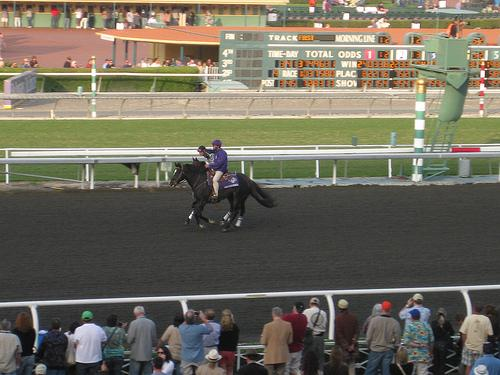Briefly describe the central event in the image and the primary figures involved. The central event is a horse race, involving two riders on horses as primary figures. Provide a brief description of the primary event happening in the image including the key participants. A horse race is underway, featuring two riders on horses competing on a dirt track. Enumerate the primary elements in the image participating in the main event. Horse race, two men riding horses, dirt track, and metal fence. Summarize the chief activity happening in the image and recognize the main participants. A horse race is the chief activity with two riders competing on horses as the main participants. Identify the major occurrence in the image and list the essential players involved. The major occurrence is a horse race, and the essential players are two men riding horses. Give a concise description of the dominant activity in the image and specify the key persons. The dominant activity is a horse race, with two men riding horses as the key persons involved. What is the main scene in the image and who are the main actors in it? The main scene is a horse race, and the main actors are two men riding horses. Mention the primary activity occurring in the image and its main participants. The primary activity is a horse race, with two men riding horses participating. State the focal point in the photograph and describe the participants involved in this key event. The focal point is a horse race where two riders on horses are racing on a dirt track. Explain the primary action happening in the picture and identify the key individuals. In the picture, a horse race is taking place with two men riding horses being the key individuals. 